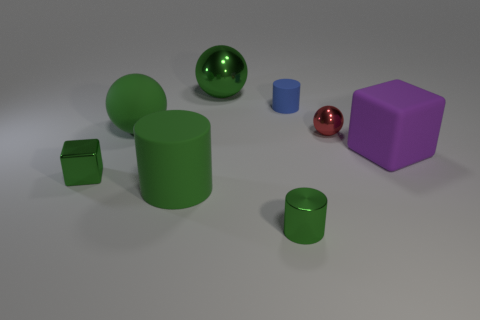Subtract all green balls. How many balls are left? 1 Add 2 small blue shiny cylinders. How many objects exist? 10 Subtract all purple cubes. How many cubes are left? 1 Subtract 1 blocks. How many blocks are left? 1 Subtract all cubes. How many objects are left? 6 Subtract all blue blocks. Subtract all blue balls. How many blocks are left? 2 Subtract all purple balls. How many blue cylinders are left? 1 Subtract all tiny matte objects. Subtract all small green shiny things. How many objects are left? 5 Add 5 small matte cylinders. How many small matte cylinders are left? 6 Add 4 blue metallic objects. How many blue metallic objects exist? 4 